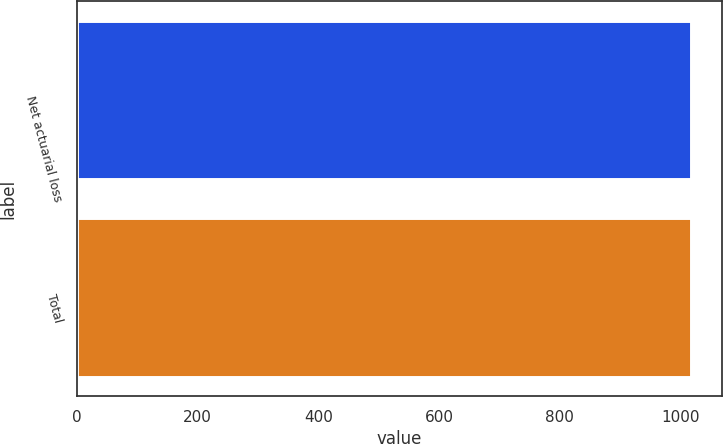<chart> <loc_0><loc_0><loc_500><loc_500><bar_chart><fcel>Net actuarial loss<fcel>Total<nl><fcel>1018<fcel>1018.1<nl></chart> 